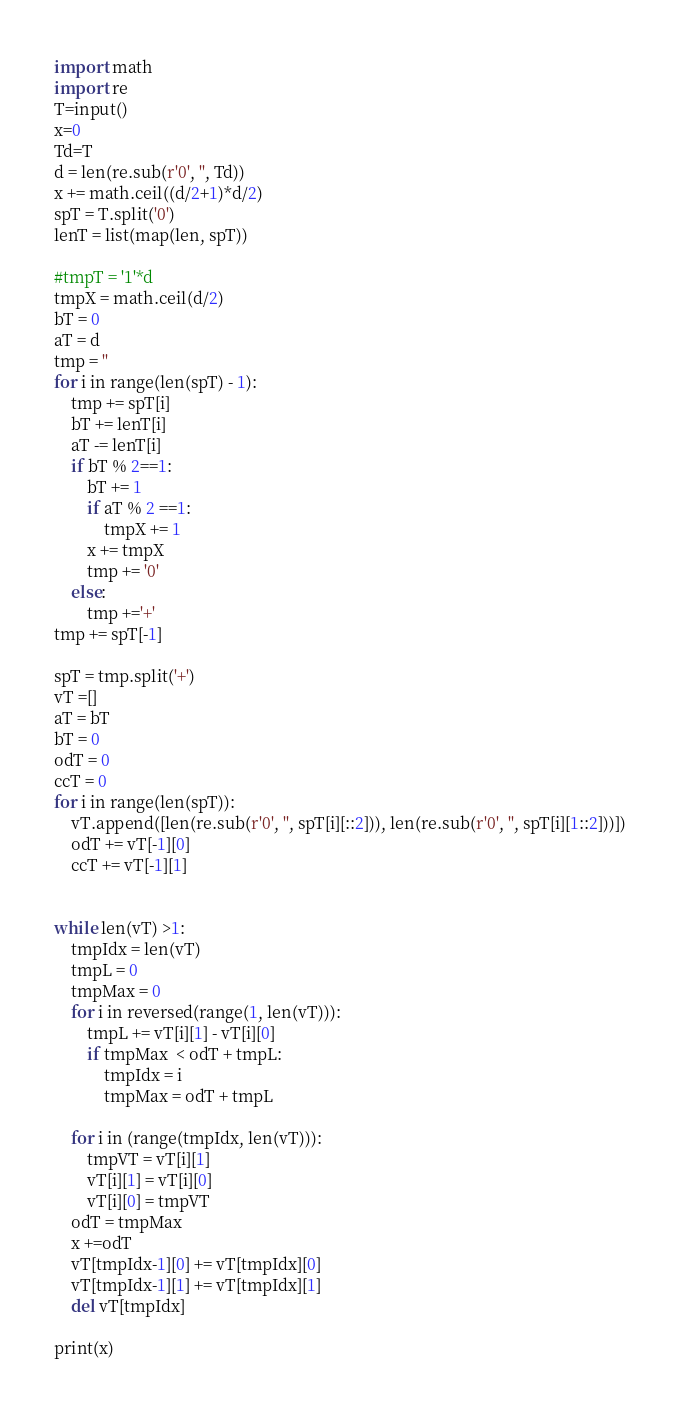Convert code to text. <code><loc_0><loc_0><loc_500><loc_500><_Python_>import math
import re
T=input()
x=0
Td=T
d = len(re.sub(r'0', '', Td))
x += math.ceil((d/2+1)*d/2)
spT = T.split('0')
lenT = list(map(len, spT))

#tmpT = '1'*d
tmpX = math.ceil(d/2)
bT = 0
aT = d
tmp = ''
for i in range(len(spT) - 1):
    tmp += spT[i]
    bT += lenT[i]
    aT -= lenT[i]
    if bT % 2==1:
        bT += 1
        if aT % 2 ==1:
            tmpX += 1
        x += tmpX
        tmp += '0'
    else:
        tmp +='+'
tmp += spT[-1]

spT = tmp.split('+')
vT =[]
aT = bT
bT = 0
odT = 0
ccT = 0
for i in range(len(spT)):
    vT.append([len(re.sub(r'0', '', spT[i][::2])), len(re.sub(r'0', '', spT[i][1::2]))])
    odT += vT[-1][0]
    ccT += vT[-1][1]


while len(vT) >1:
    tmpIdx = len(vT)
    tmpL = 0
    tmpMax = 0
    for i in reversed(range(1, len(vT))):
        tmpL += vT[i][1] - vT[i][0]
        if tmpMax  < odT + tmpL:
            tmpIdx = i
            tmpMax = odT + tmpL

    for i in (range(tmpIdx, len(vT))):
        tmpVT = vT[i][1]
        vT[i][1] = vT[i][0]
        vT[i][0] = tmpVT
    odT = tmpMax
    x +=odT
    vT[tmpIdx-1][0] += vT[tmpIdx][0]
    vT[tmpIdx-1][1] += vT[tmpIdx][1]
    del vT[tmpIdx]

print(x)</code> 